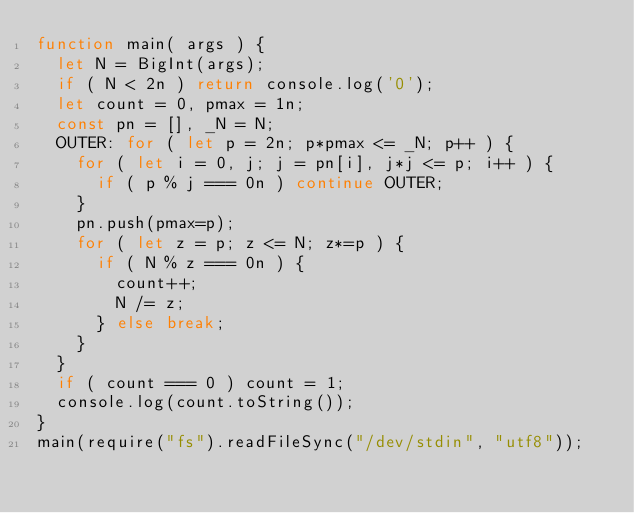<code> <loc_0><loc_0><loc_500><loc_500><_JavaScript_>function main( args ) {
  let N = BigInt(args);
  if ( N < 2n ) return console.log('0');
  let count = 0, pmax = 1n;
  const pn = [], _N = N;
  OUTER: for ( let p = 2n; p*pmax <= _N; p++ ) {
    for ( let i = 0, j; j = pn[i], j*j <= p; i++ ) {
      if ( p % j === 0n ) continue OUTER;
    }
    pn.push(pmax=p);
    for ( let z = p; z <= N; z*=p ) {
      if ( N % z === 0n ) {
        count++;
        N /= z;
      } else break;
    }
  }
  if ( count === 0 ) count = 1;
  console.log(count.toString());
}
main(require("fs").readFileSync("/dev/stdin", "utf8"));</code> 